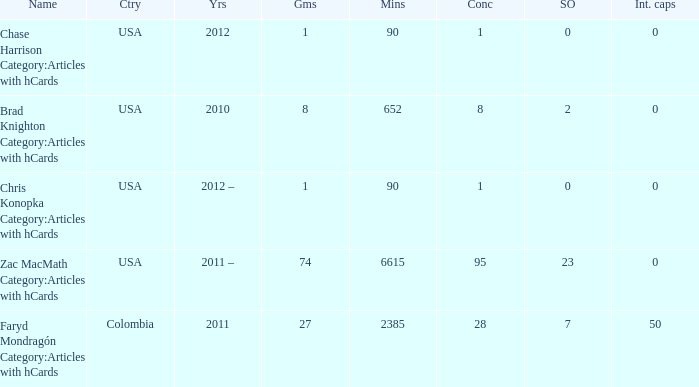What is the lowest overall amount of shutouts? 0.0. 